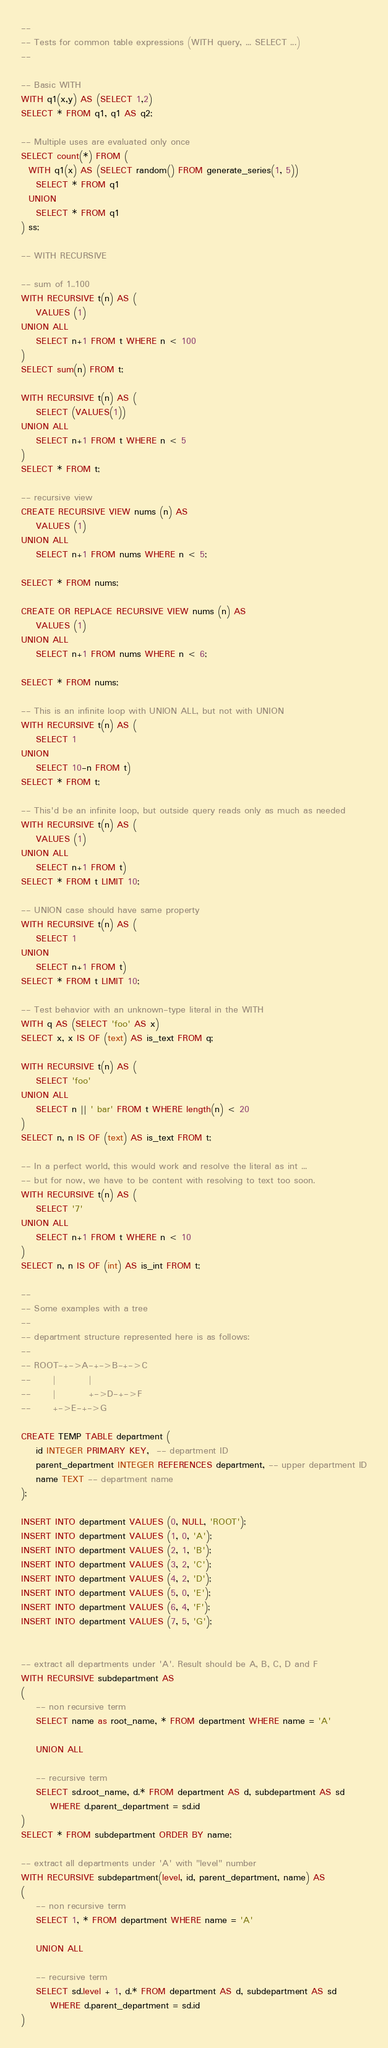<code> <loc_0><loc_0><loc_500><loc_500><_SQL_>--
-- Tests for common table expressions (WITH query, ... SELECT ...)
--

-- Basic WITH
WITH q1(x,y) AS (SELECT 1,2)
SELECT * FROM q1, q1 AS q2;

-- Multiple uses are evaluated only once
SELECT count(*) FROM (
  WITH q1(x) AS (SELECT random() FROM generate_series(1, 5))
    SELECT * FROM q1
  UNION
    SELECT * FROM q1
) ss;

-- WITH RECURSIVE

-- sum of 1..100
WITH RECURSIVE t(n) AS (
    VALUES (1)
UNION ALL
    SELECT n+1 FROM t WHERE n < 100
)
SELECT sum(n) FROM t;

WITH RECURSIVE t(n) AS (
    SELECT (VALUES(1))
UNION ALL
    SELECT n+1 FROM t WHERE n < 5
)
SELECT * FROM t;

-- recursive view
CREATE RECURSIVE VIEW nums (n) AS
    VALUES (1)
UNION ALL
    SELECT n+1 FROM nums WHERE n < 5;

SELECT * FROM nums;

CREATE OR REPLACE RECURSIVE VIEW nums (n) AS
    VALUES (1)
UNION ALL
    SELECT n+1 FROM nums WHERE n < 6;

SELECT * FROM nums;

-- This is an infinite loop with UNION ALL, but not with UNION
WITH RECURSIVE t(n) AS (
    SELECT 1
UNION
    SELECT 10-n FROM t)
SELECT * FROM t;

-- This'd be an infinite loop, but outside query reads only as much as needed
WITH RECURSIVE t(n) AS (
    VALUES (1)
UNION ALL
    SELECT n+1 FROM t)
SELECT * FROM t LIMIT 10;

-- UNION case should have same property
WITH RECURSIVE t(n) AS (
    SELECT 1
UNION
    SELECT n+1 FROM t)
SELECT * FROM t LIMIT 10;

-- Test behavior with an unknown-type literal in the WITH
WITH q AS (SELECT 'foo' AS x)
SELECT x, x IS OF (text) AS is_text FROM q;

WITH RECURSIVE t(n) AS (
    SELECT 'foo'
UNION ALL
    SELECT n || ' bar' FROM t WHERE length(n) < 20
)
SELECT n, n IS OF (text) AS is_text FROM t;

-- In a perfect world, this would work and resolve the literal as int ...
-- but for now, we have to be content with resolving to text too soon.
WITH RECURSIVE t(n) AS (
    SELECT '7'
UNION ALL
    SELECT n+1 FROM t WHERE n < 10
)
SELECT n, n IS OF (int) AS is_int FROM t;

--
-- Some examples with a tree
--
-- department structure represented here is as follows:
--
-- ROOT-+->A-+->B-+->C
--      |         |
--      |         +->D-+->F
--      +->E-+->G

CREATE TEMP TABLE department (
	id INTEGER PRIMARY KEY,  -- department ID
	parent_department INTEGER REFERENCES department, -- upper department ID
	name TEXT -- department name
);

INSERT INTO department VALUES (0, NULL, 'ROOT');
INSERT INTO department VALUES (1, 0, 'A');
INSERT INTO department VALUES (2, 1, 'B');
INSERT INTO department VALUES (3, 2, 'C');
INSERT INTO department VALUES (4, 2, 'D');
INSERT INTO department VALUES (5, 0, 'E');
INSERT INTO department VALUES (6, 4, 'F');
INSERT INTO department VALUES (7, 5, 'G');


-- extract all departments under 'A'. Result should be A, B, C, D and F
WITH RECURSIVE subdepartment AS
(
	-- non recursive term
	SELECT name as root_name, * FROM department WHERE name = 'A'

	UNION ALL

	-- recursive term
	SELECT sd.root_name, d.* FROM department AS d, subdepartment AS sd
		WHERE d.parent_department = sd.id
)
SELECT * FROM subdepartment ORDER BY name;

-- extract all departments under 'A' with "level" number
WITH RECURSIVE subdepartment(level, id, parent_department, name) AS
(
	-- non recursive term
	SELECT 1, * FROM department WHERE name = 'A'

	UNION ALL

	-- recursive term
	SELECT sd.level + 1, d.* FROM department AS d, subdepartment AS sd
		WHERE d.parent_department = sd.id
)</code> 